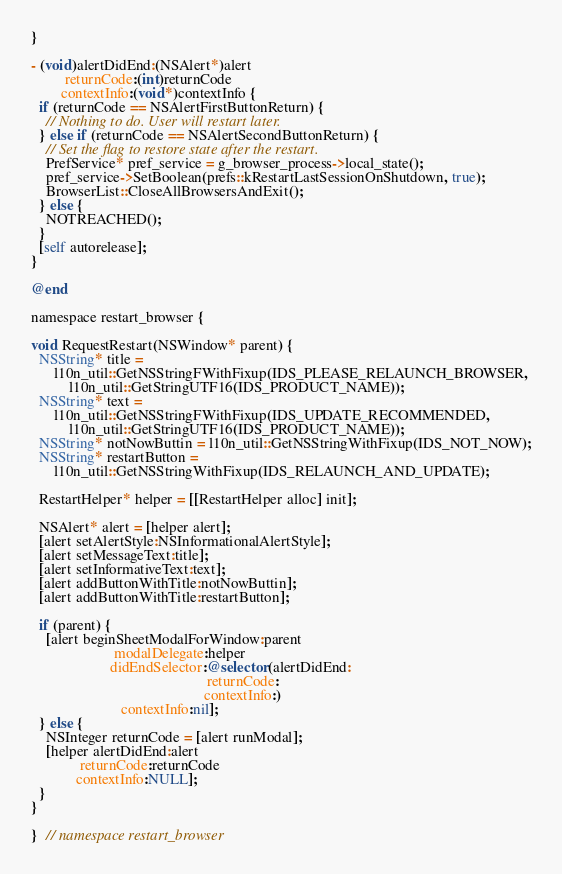<code> <loc_0><loc_0><loc_500><loc_500><_ObjectiveC_>}

- (void)alertDidEnd:(NSAlert*)alert
         returnCode:(int)returnCode
        contextInfo:(void*)contextInfo {
  if (returnCode == NSAlertFirstButtonReturn) {
    // Nothing to do. User will restart later.
  } else if (returnCode == NSAlertSecondButtonReturn) {
    // Set the flag to restore state after the restart.
    PrefService* pref_service = g_browser_process->local_state();
    pref_service->SetBoolean(prefs::kRestartLastSessionOnShutdown, true);
    BrowserList::CloseAllBrowsersAndExit();
  } else {
    NOTREACHED();
  }
  [self autorelease];
}

@end

namespace restart_browser {

void RequestRestart(NSWindow* parent) {
  NSString* title =
      l10n_util::GetNSStringFWithFixup(IDS_PLEASE_RELAUNCH_BROWSER,
          l10n_util::GetStringUTF16(IDS_PRODUCT_NAME));
  NSString* text =
      l10n_util::GetNSStringFWithFixup(IDS_UPDATE_RECOMMENDED,
          l10n_util::GetStringUTF16(IDS_PRODUCT_NAME));
  NSString* notNowButtin = l10n_util::GetNSStringWithFixup(IDS_NOT_NOW);
  NSString* restartButton =
      l10n_util::GetNSStringWithFixup(IDS_RELAUNCH_AND_UPDATE);

  RestartHelper* helper = [[RestartHelper alloc] init];

  NSAlert* alert = [helper alert];
  [alert setAlertStyle:NSInformationalAlertStyle];
  [alert setMessageText:title];
  [alert setInformativeText:text];
  [alert addButtonWithTitle:notNowButtin];
  [alert addButtonWithTitle:restartButton];

  if (parent) {
    [alert beginSheetModalForWindow:parent
                      modalDelegate:helper
                     didEndSelector:@selector(alertDidEnd:
                                               returnCode:
                                              contextInfo:)
                        contextInfo:nil];
  } else {
    NSInteger returnCode = [alert runModal];
    [helper alertDidEnd:alert
             returnCode:returnCode
            contextInfo:NULL];
  }
}

}  // namespace restart_browser
</code> 